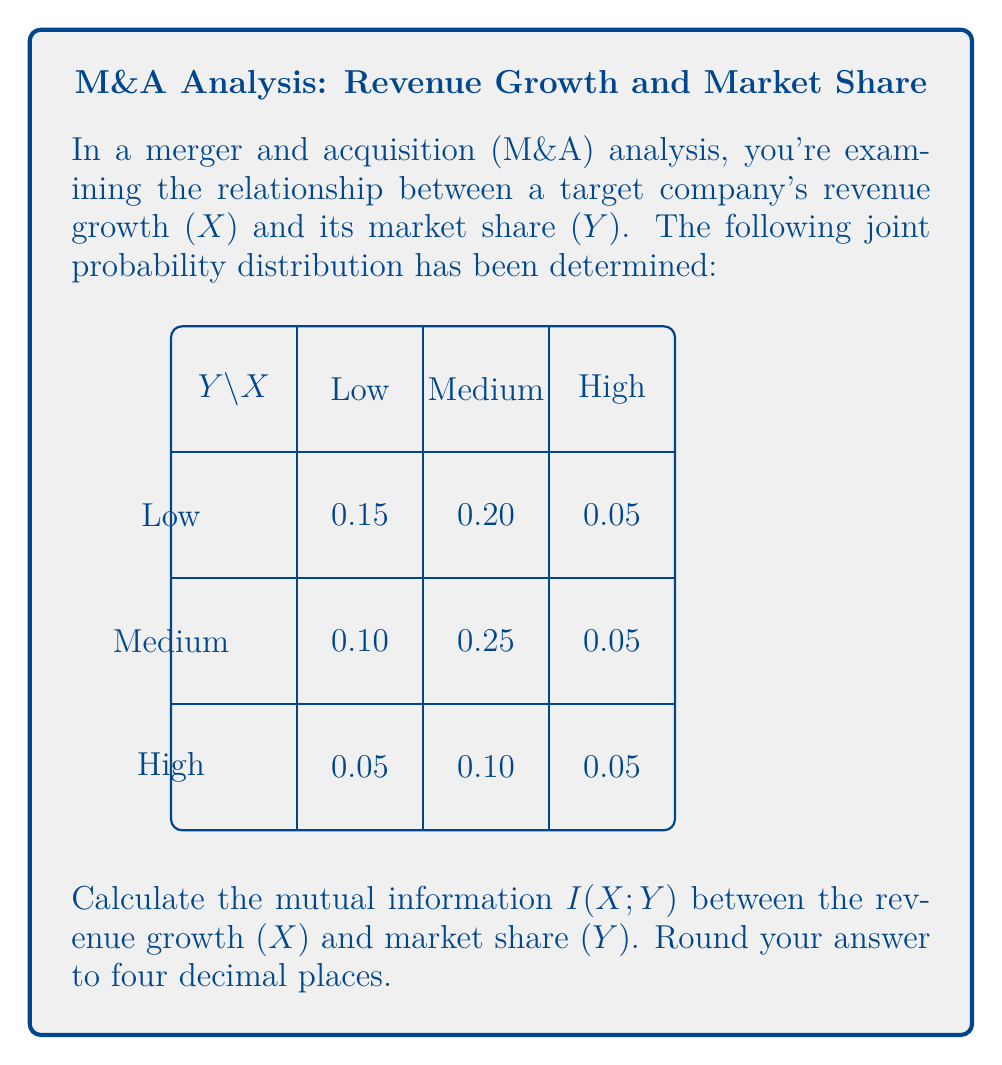Solve this math problem. To calculate the mutual information $I(X;Y)$, we'll follow these steps:

1) First, we need to calculate the marginal probabilities for X and Y:

   $P(X = \text{Low}) = 0.15 + 0.10 + 0.05 = 0.30$
   $P(X = \text{Medium}) = 0.20 + 0.25 + 0.10 = 0.55$
   $P(X = \text{High}) = 0.05 + 0.05 + 0.05 = 0.15$

   $P(Y = \text{Low}) = 0.15 + 0.20 + 0.05 = 0.40$
   $P(Y = \text{Medium}) = 0.10 + 0.25 + 0.05 = 0.40$
   $P(Y = \text{High}) = 0.05 + 0.10 + 0.05 = 0.20$

2) The mutual information is defined as:

   $$I(X;Y) = \sum_{x}\sum_{y} P(x,y) \log_2\left(\frac{P(x,y)}{P(x)P(y)}\right)$$

3) Let's calculate each term:

   $0.15 \log_2(0.15/(0.30*0.40)) = 0.15 \log_2(1.25) = 0.0433$
   $0.20 \log_2(0.20/(0.55*0.40)) = 0.20 \log_2(0.9091) = -0.0134$
   $0.05 \log_2(0.05/(0.15*0.40)) = 0.05 \log_2(0.8333) = -0.0067$
   $0.10 \log_2(0.10/(0.30*0.40)) = 0.10 \log_2(0.8333) = -0.0134$
   $0.25 \log_2(0.25/(0.55*0.40)) = 0.25 \log_2(1.1364) = 0.0389$
   $0.05 \log_2(0.05/(0.15*0.40)) = 0.05 \log_2(0.8333) = -0.0067$
   $0.05 \log_2(0.05/(0.30*0.20)) = 0.05 \log_2(0.8333) = -0.0067$
   $0.10 \log_2(0.10/(0.55*0.20)) = 0.10 \log_2(0.9091) = -0.0067$
   $0.05 \log_2(0.05/(0.15*0.20)) = 0.05 \log_2(1.6667) = 0.0368$

4) Sum all these terms:

   $I(X;Y) = 0.0433 - 0.0134 - 0.0067 - 0.0134 + 0.0389 - 0.0067 - 0.0067 - 0.0067 + 0.0368 = 0.0654$

5) Rounding to four decimal places:

   $I(X;Y) = 0.0654 \approx 0.0654$ bits

This mutual information value indicates the amount of information shared between the revenue growth and market share variables in our M&A analysis.
Answer: 0.0654 bits 